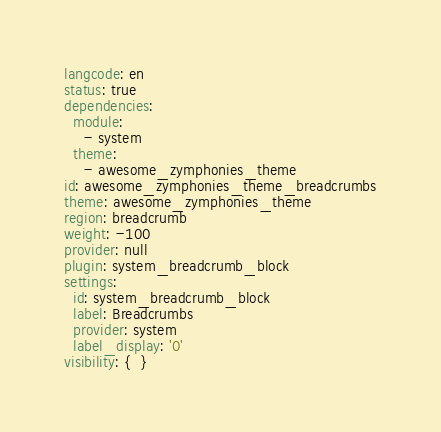Convert code to text. <code><loc_0><loc_0><loc_500><loc_500><_YAML_>langcode: en
status: true
dependencies:
  module:
    - system
  theme:
    - awesome_zymphonies_theme
id: awesome_zymphonies_theme_breadcrumbs
theme: awesome_zymphonies_theme
region: breadcrumb
weight: -100
provider: null
plugin: system_breadcrumb_block
settings:
  id: system_breadcrumb_block
  label: Breadcrumbs
  provider: system
  label_display: '0'
visibility: {  }
</code> 